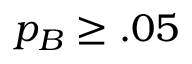<formula> <loc_0><loc_0><loc_500><loc_500>p _ { B } \geq . 0 5</formula> 